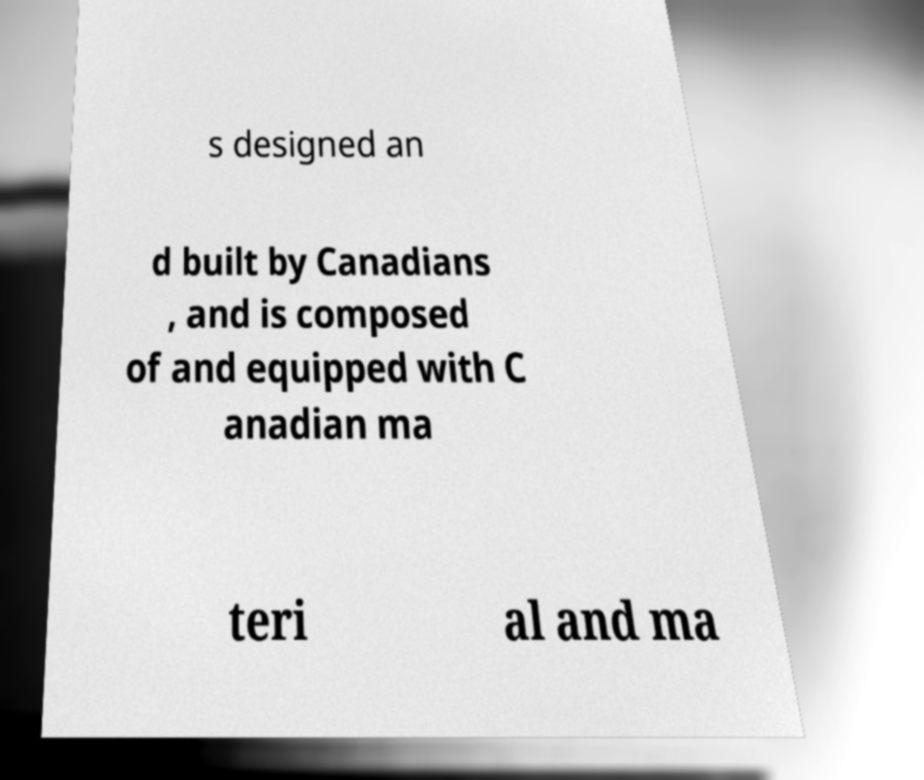Can you accurately transcribe the text from the provided image for me? s designed an d built by Canadians , and is composed of and equipped with C anadian ma teri al and ma 